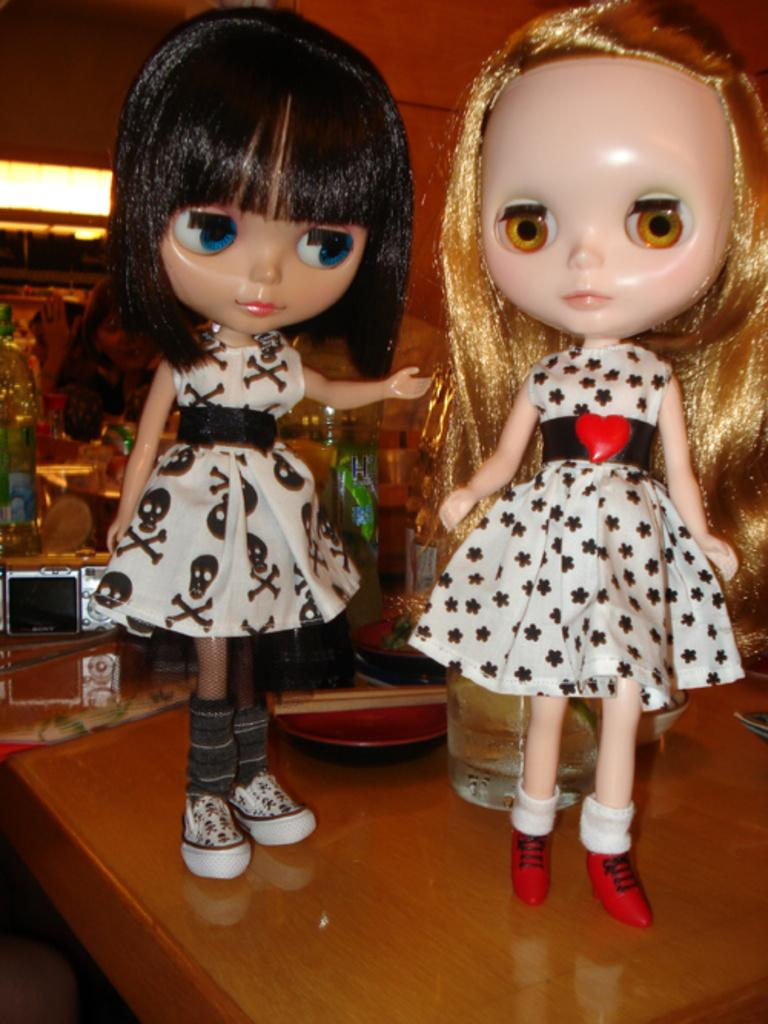How many dolls are on the table in the image? There are two dolls on the table in the image. What else is on the table besides the dolls? There is a glass and a plate on the table. Can you describe the objects in the background of the image? Unfortunately, the provided facts do not give any information about the objects in the background. What type of question is being asked by the doll on the left side of the image? There is no indication in the image that the dolls are asking any questions, and therefore we cannot answer this question. 